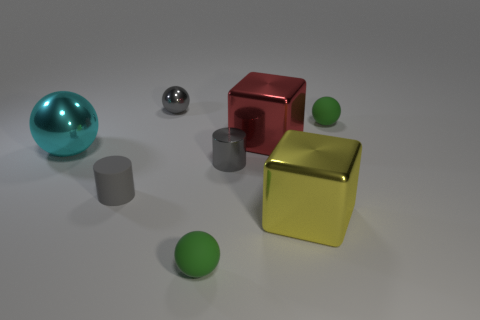Is the material of the large ball the same as the big red block?
Provide a short and direct response. Yes. There is a metal cylinder; what number of small things are on the left side of it?
Offer a terse response. 3. There is a big thing that is both in front of the big red metallic cube and to the left of the big yellow metal block; what material is it?
Offer a very short reply. Metal. How many green spheres have the same size as the gray metal sphere?
Make the answer very short. 2. There is a tiny metal thing that is on the right side of the green thing that is to the left of the metal cylinder; what color is it?
Your response must be concise. Gray. Are there any big red things?
Your answer should be very brief. Yes. Does the large red metallic thing have the same shape as the gray matte thing?
Your response must be concise. No. What is the size of the ball that is the same color as the matte cylinder?
Your response must be concise. Small. How many big yellow things are to the left of the big metal thing in front of the large cyan thing?
Provide a short and direct response. 0. What number of green things are both in front of the red metal object and to the right of the yellow metal cube?
Ensure brevity in your answer.  0. 